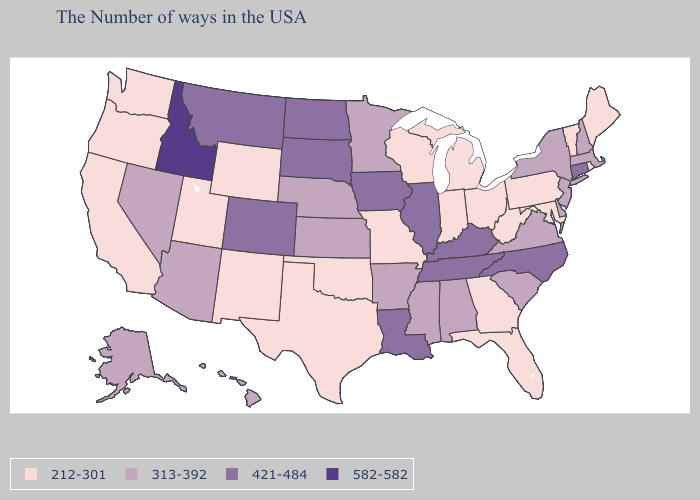Name the states that have a value in the range 582-582?
Answer briefly. Idaho. Name the states that have a value in the range 313-392?
Short answer required. Massachusetts, New Hampshire, New York, New Jersey, Delaware, Virginia, South Carolina, Alabama, Mississippi, Arkansas, Minnesota, Kansas, Nebraska, Arizona, Nevada, Alaska, Hawaii. Among the states that border Virginia , does Maryland have the lowest value?
Concise answer only. Yes. Does the first symbol in the legend represent the smallest category?
Short answer required. Yes. Does Idaho have the highest value in the USA?
Be succinct. Yes. What is the value of Nevada?
Answer briefly. 313-392. Does the map have missing data?
Be succinct. No. Does Rhode Island have a lower value than Wisconsin?
Concise answer only. No. Does Washington have the highest value in the West?
Short answer required. No. What is the value of New Jersey?
Be succinct. 313-392. Does the map have missing data?
Keep it brief. No. Name the states that have a value in the range 582-582?
Quick response, please. Idaho. Among the states that border Virginia , which have the lowest value?
Short answer required. Maryland, West Virginia. Does the map have missing data?
Be succinct. No. What is the value of Hawaii?
Answer briefly. 313-392. 